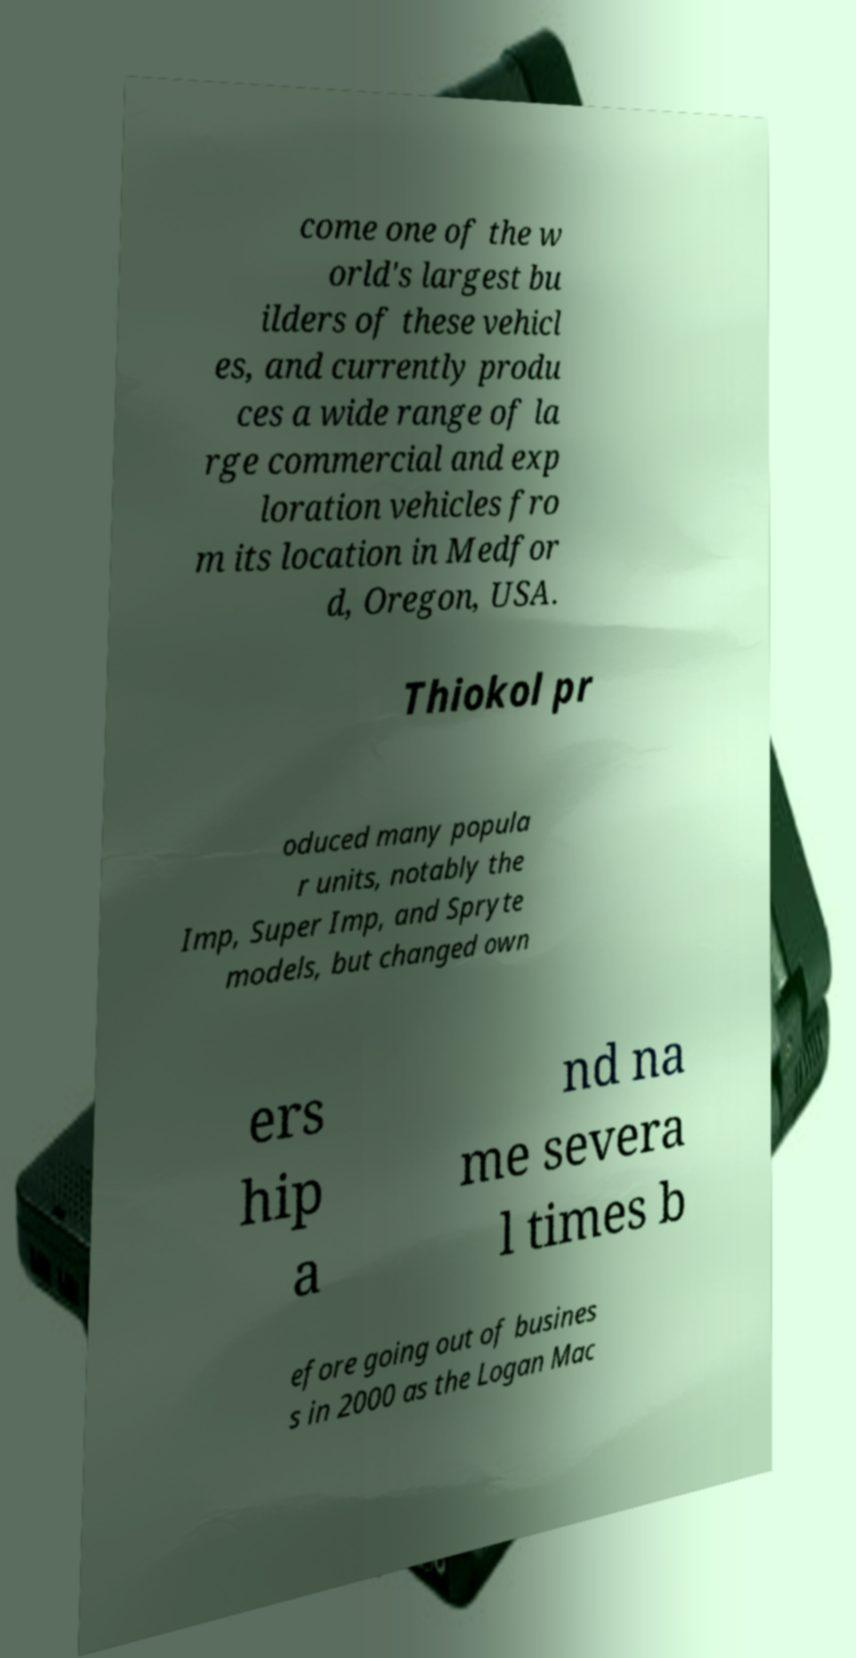Could you assist in decoding the text presented in this image and type it out clearly? come one of the w orld's largest bu ilders of these vehicl es, and currently produ ces a wide range of la rge commercial and exp loration vehicles fro m its location in Medfor d, Oregon, USA. Thiokol pr oduced many popula r units, notably the Imp, Super Imp, and Spryte models, but changed own ers hip a nd na me severa l times b efore going out of busines s in 2000 as the Logan Mac 